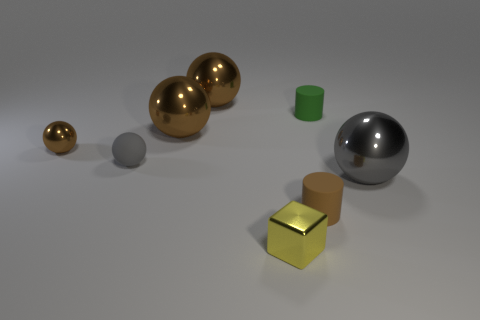Is there a tiny green matte cylinder?
Ensure brevity in your answer.  Yes. There is a matte thing that is to the right of the small gray matte ball and behind the large gray metallic object; what color is it?
Ensure brevity in your answer.  Green. Do the gray shiny thing on the right side of the small gray matte sphere and the sphere behind the green thing have the same size?
Keep it short and to the point. Yes. How many other things are there of the same size as the yellow metallic object?
Offer a very short reply. 4. How many tiny brown metallic spheres are behind the thing in front of the brown matte cylinder?
Offer a very short reply. 1. Are there fewer cylinders in front of the brown matte cylinder than purple shiny cylinders?
Give a very brief answer. No. The small metallic thing that is behind the gray thing in front of the small rubber ball behind the gray metal thing is what shape?
Provide a succinct answer. Sphere. Does the tiny yellow object have the same shape as the large gray thing?
Make the answer very short. No. What number of other things are there of the same shape as the yellow object?
Offer a very short reply. 0. There is a shiny ball that is the same size as the green cylinder; what is its color?
Offer a terse response. Brown. 